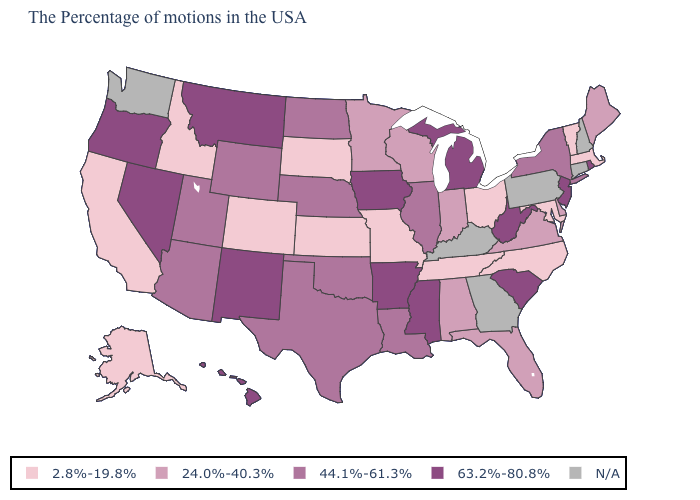Does West Virginia have the lowest value in the USA?
Answer briefly. No. What is the value of Connecticut?
Give a very brief answer. N/A. What is the value of North Dakota?
Give a very brief answer. 44.1%-61.3%. What is the value of Pennsylvania?
Be succinct. N/A. Name the states that have a value in the range 44.1%-61.3%?
Concise answer only. New York, Illinois, Louisiana, Nebraska, Oklahoma, Texas, North Dakota, Wyoming, Utah, Arizona. What is the value of Rhode Island?
Answer briefly. 63.2%-80.8%. Name the states that have a value in the range 2.8%-19.8%?
Give a very brief answer. Massachusetts, Vermont, Maryland, North Carolina, Ohio, Tennessee, Missouri, Kansas, South Dakota, Colorado, Idaho, California, Alaska. What is the lowest value in the USA?
Keep it brief. 2.8%-19.8%. Which states hav the highest value in the West?
Be succinct. New Mexico, Montana, Nevada, Oregon, Hawaii. Does the first symbol in the legend represent the smallest category?
Concise answer only. Yes. Does Nevada have the lowest value in the USA?
Concise answer only. No. Which states have the lowest value in the USA?
Answer briefly. Massachusetts, Vermont, Maryland, North Carolina, Ohio, Tennessee, Missouri, Kansas, South Dakota, Colorado, Idaho, California, Alaska. Name the states that have a value in the range 2.8%-19.8%?
Concise answer only. Massachusetts, Vermont, Maryland, North Carolina, Ohio, Tennessee, Missouri, Kansas, South Dakota, Colorado, Idaho, California, Alaska. Name the states that have a value in the range 2.8%-19.8%?
Write a very short answer. Massachusetts, Vermont, Maryland, North Carolina, Ohio, Tennessee, Missouri, Kansas, South Dakota, Colorado, Idaho, California, Alaska. Name the states that have a value in the range 63.2%-80.8%?
Concise answer only. Rhode Island, New Jersey, South Carolina, West Virginia, Michigan, Mississippi, Arkansas, Iowa, New Mexico, Montana, Nevada, Oregon, Hawaii. 